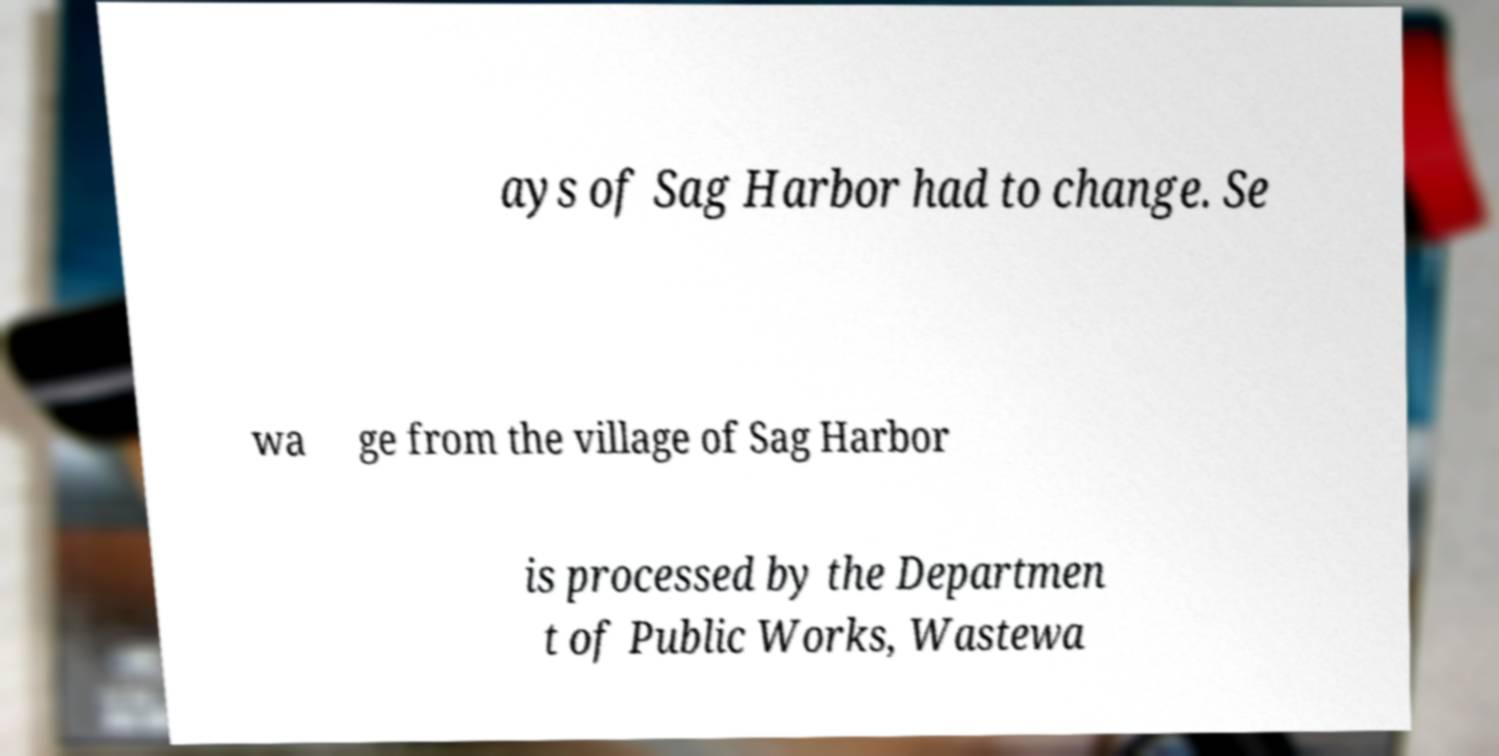I need the written content from this picture converted into text. Can you do that? ays of Sag Harbor had to change. Se wa ge from the village of Sag Harbor is processed by the Departmen t of Public Works, Wastewa 